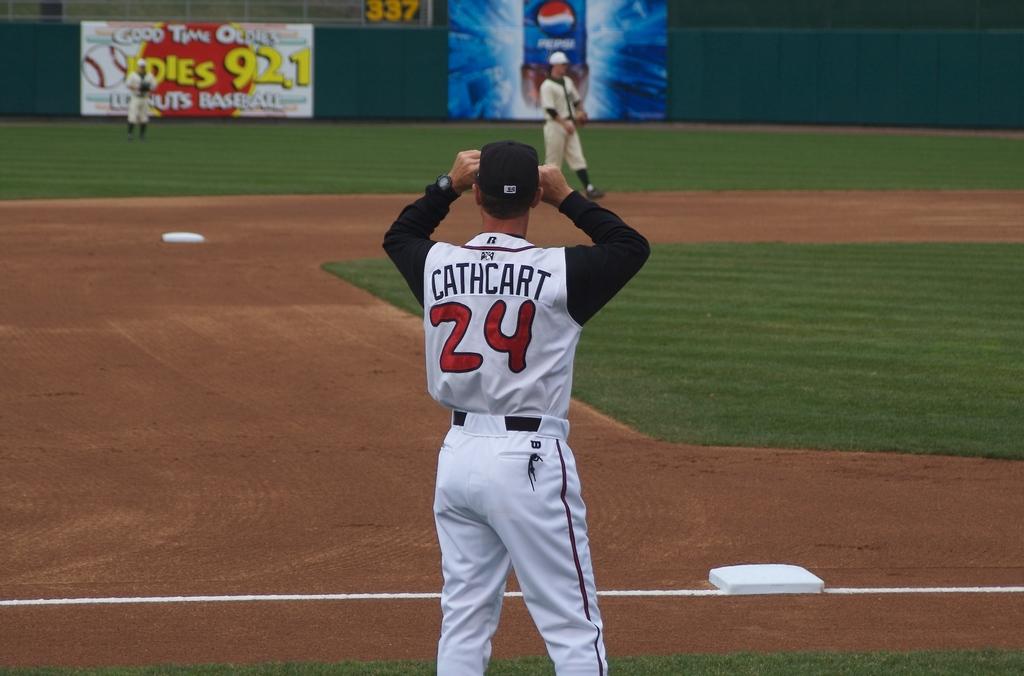What is the name of this player?
Provide a short and direct response. Cathcart. 